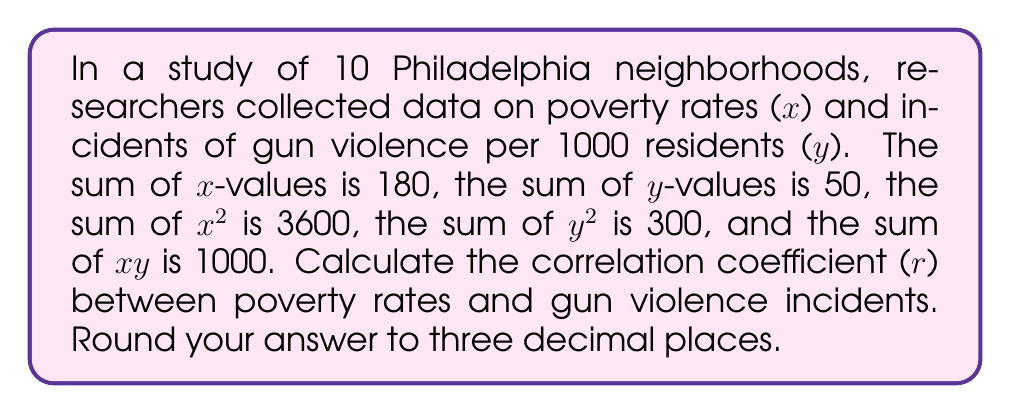Teach me how to tackle this problem. To calculate the correlation coefficient (r), we'll use the formula:

$$ r = \frac{n\sum xy - \sum x \sum y}{\sqrt{[n\sum x^2 - (\sum x)^2][n\sum y^2 - (\sum y)^2]}} $$

Given:
n = 10 (number of neighborhoods)
$\sum x = 180$
$\sum y = 50$
$\sum x^2 = 3600$
$\sum y^2 = 300$
$\sum xy = 1000$

Step 1: Calculate $n\sum xy$
$10 * 1000 = 10000$

Step 2: Calculate $\sum x \sum y$
$180 * 50 = 9000$

Step 3: Calculate the numerator
$10000 - 9000 = 1000$

Step 4: Calculate $n\sum x^2$
$10 * 3600 = 36000$

Step 5: Calculate $(\sum x)^2$
$180^2 = 32400$

Step 6: Calculate $n\sum y^2$
$10 * 300 = 3000$

Step 7: Calculate $(\sum y)^2$
$50^2 = 2500$

Step 8: Calculate the denominator
$\sqrt{[36000 - 32400][3000 - 2500]} = \sqrt{3600 * 500} = \sqrt{1800000} = 1341.64$

Step 9: Calculate r
$r = \frac{1000}{1341.64} = 0.745$

Step 10: Round to three decimal places
$r = 0.745$
Answer: 0.745 